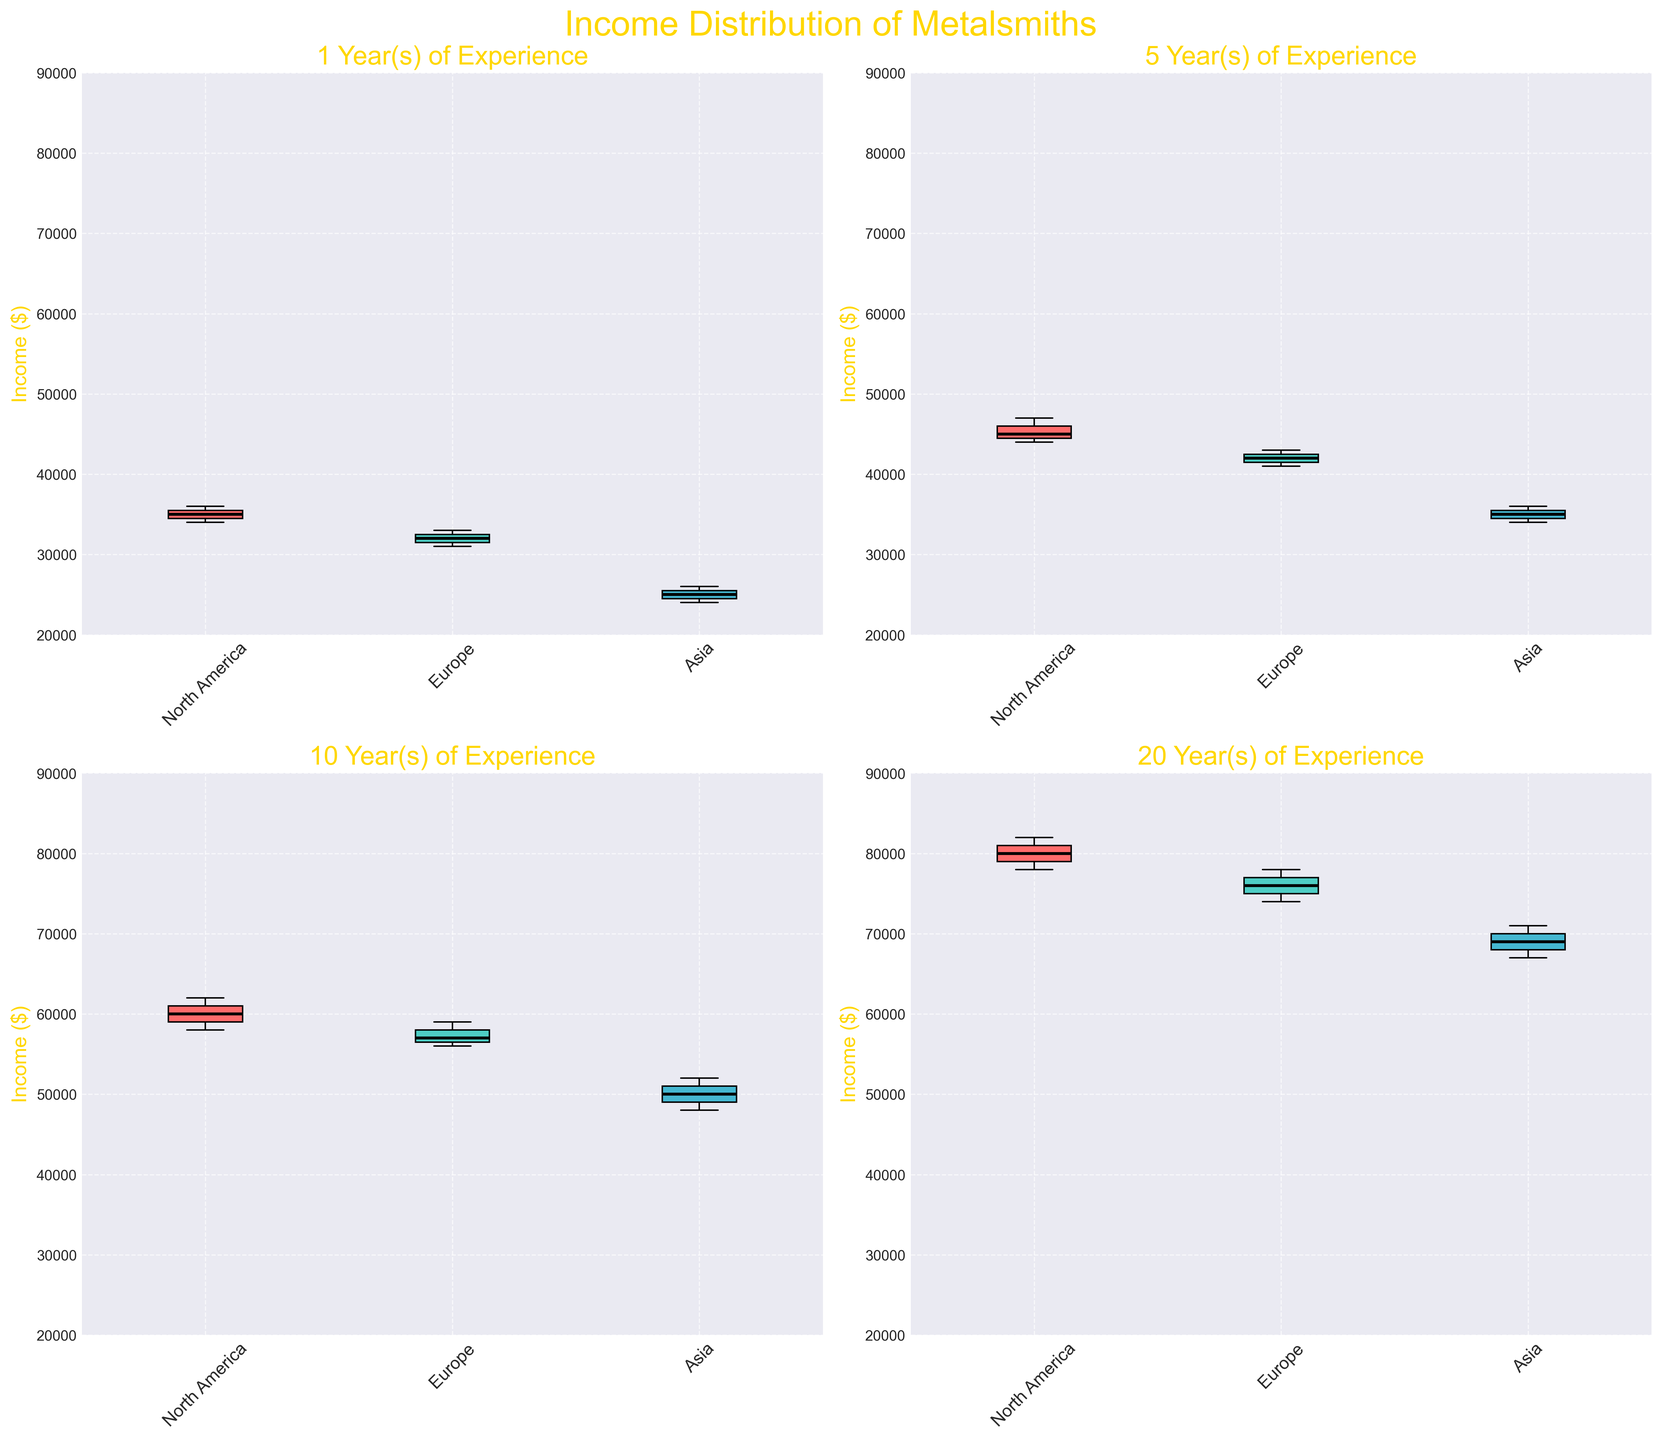How many geographical regions are represented in each box plot subfigure? Each subfigure has three different box plots, one for each of the geographical regions: North America, Europe, and Asia.
Answer: Three Which region has the highest median income for metalsmiths with 20 years of experience? In the subfigure for 20 years of experience, North America has the highest median line which appears around $80,000.
Answer: North America Which region shows the lowest income distribution for metalsmiths with 1 year of experience? For the subfigure of 1 year of experience, Asia has the lowest box plot with the median around $25,000.
Answer: Asia How does the median income of metalsmiths in Europe change from 1 year to 20 years of experience? By observing the median lines in the subfigures, Europe's median income starts at around $32,000 for 1 year and increases to around $76,000 for 20 years. The increase is $76,000 - $32,000 = $44,000.
Answer: Increases by $44,000 Which experience level shows the most consistent income distribution (least spread) for North America? The spread of the box plot for North America with 20 years of experience appears to be the smallest, indicating the most consistent distribution.
Answer: 20 years Compare the interquartile range (IQR) for metalsmiths with 5 years of experience between North America and Asia. The IQR is the distance between the lower and upper quartiles (the bottom and top of the box). For 5 years, North America has a narrower box plot compared to Asia, indicating a smaller IQR.
Answer: North America has a smaller IQR Which geographical region shows a larger increase in median income between 5 years and 10 years of experience? Comparing the median lines from 5 years to 10 years, North America’s median significantly increases from about $45,000 to $60,000, which is larger compared to Europe and Asia.
Answer: North America Is there any region where the median income doubles from 1 year of experience to 20 years of experience? For North America, the median income increases from around $35,000 for 1 year to about $80,000 for 20 years, more than doubling.
Answer: Yes, North America Across all experience levels, which region generally shows lower incomes compared to others? In all subfigures, Asia consistently shows lower box plots compared to North America and Europe.
Answer: Asia Which subfigure shows the largest difference between the highest and lowest individual incomes? The subfigure for 20 years of experience has the largest spread between the highest (around $82,000) and the lowest (around $67,000) individual incomes.
Answer: 20 years 